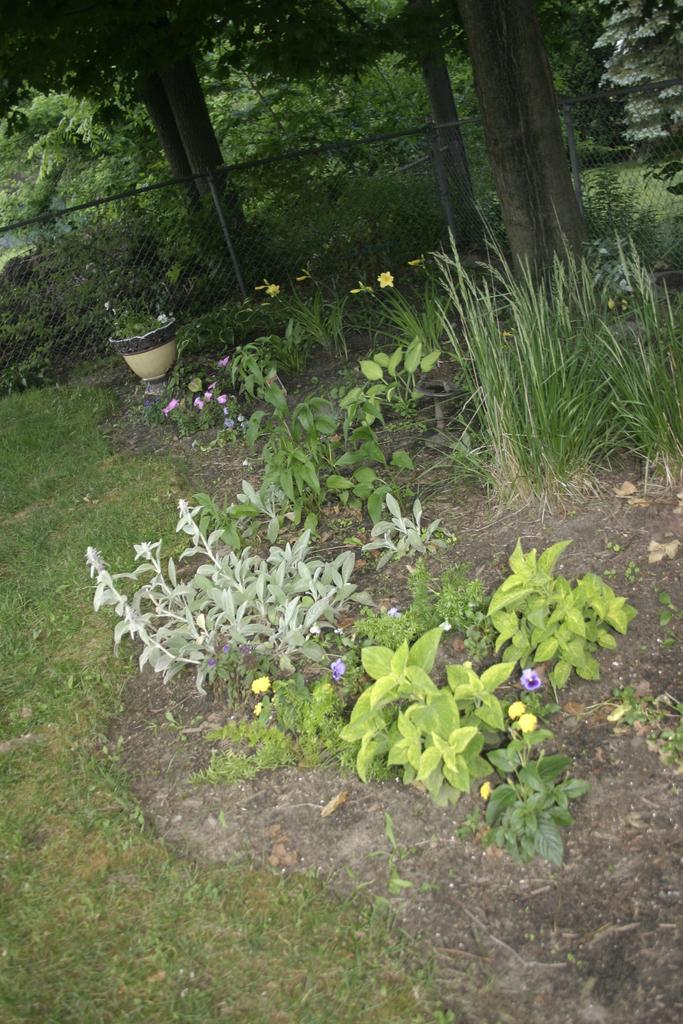How would you summarize this image in a sentence or two? In this picture we can see some trees, grass and plants. 